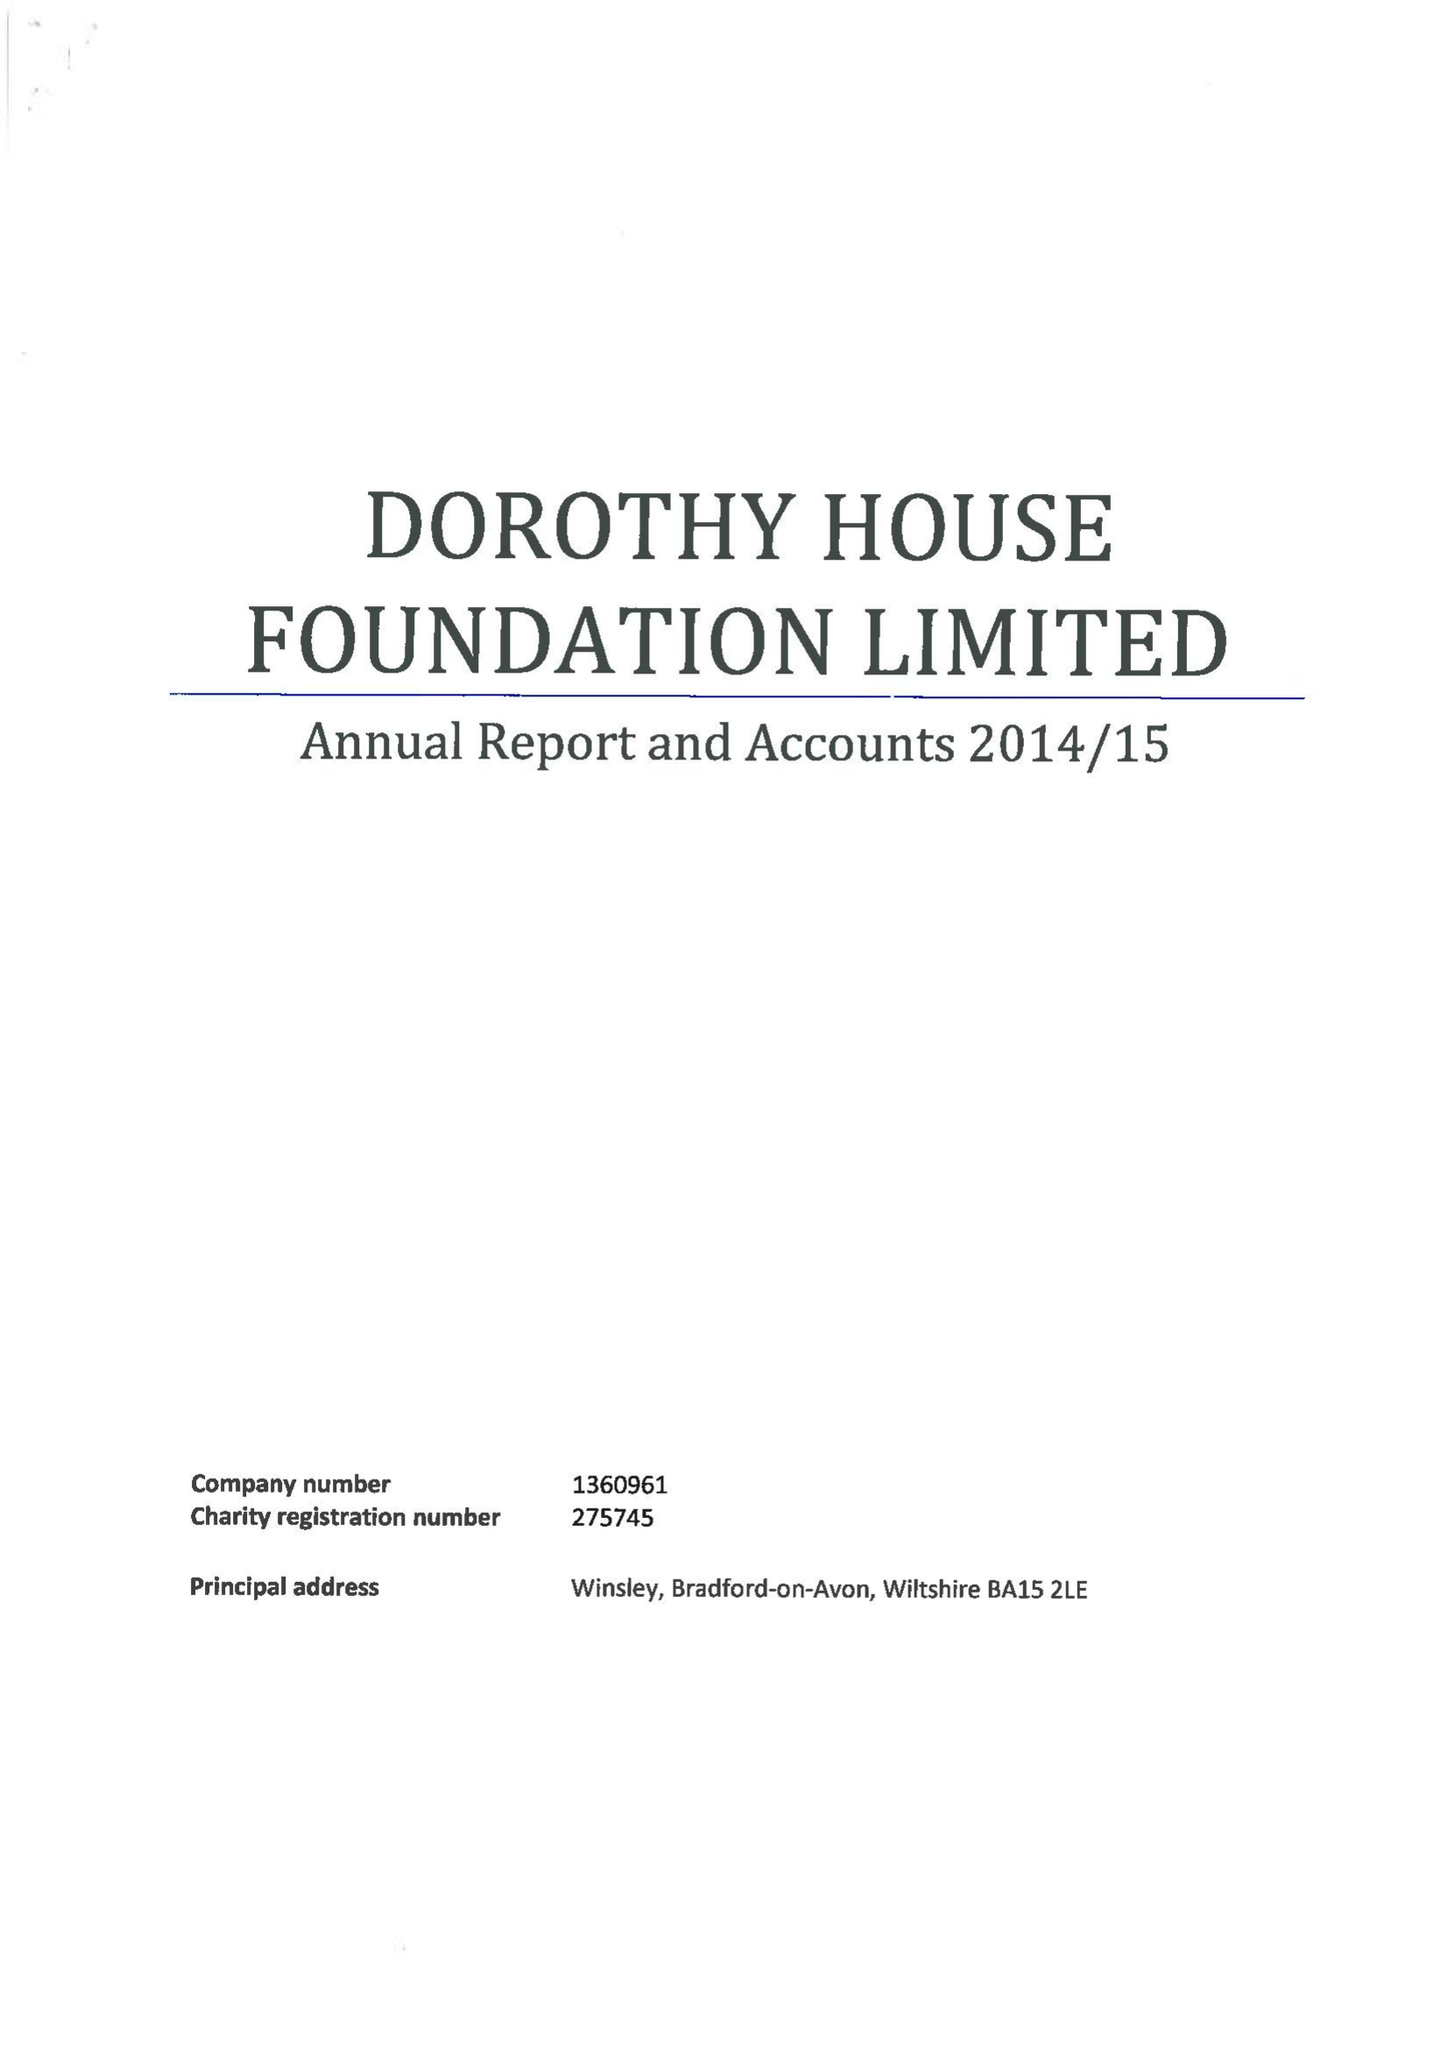What is the value for the charity_number?
Answer the question using a single word or phrase. 275745 